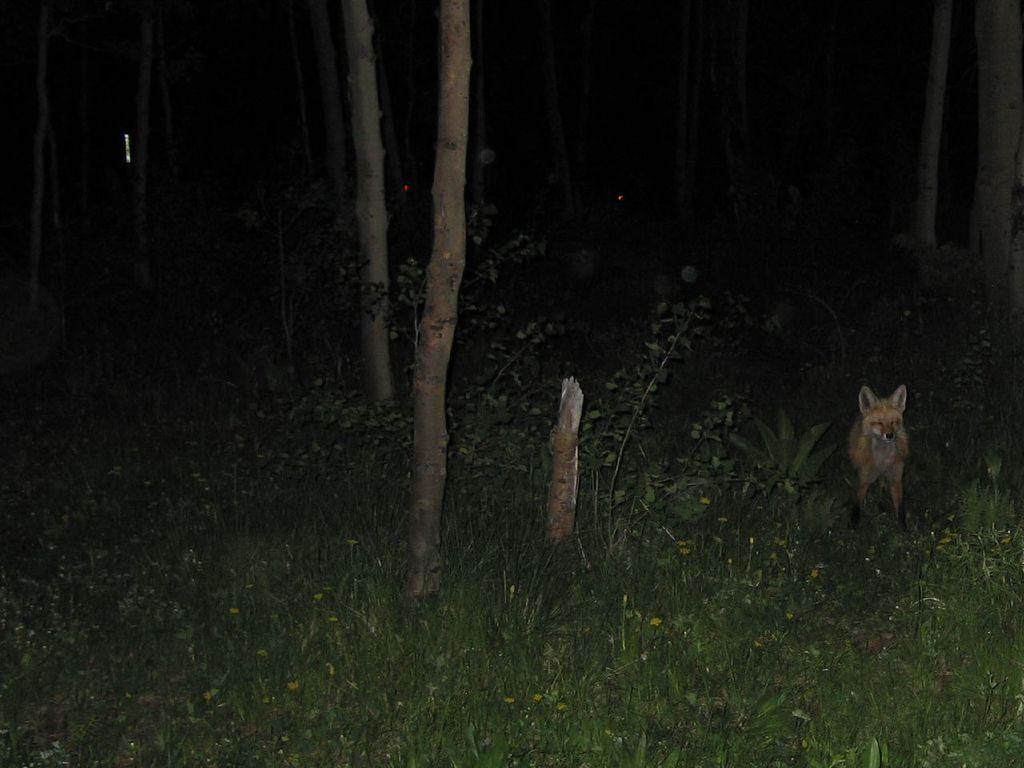What type of animal is on the right side of the image? The specific type of animal cannot be determined from the provided facts. What can be found on the ground in the image? There are plants on the ground in the image. What type of vegetation is visible in the image? There is grass visible in the image. What other type of vegetation is present in the image? There are trees in the image. How many actors are present in the image? There is no actor present in the image. What type of lock can be seen securing the plants in the image? There is no lock present in the image; the plants are not secured. 